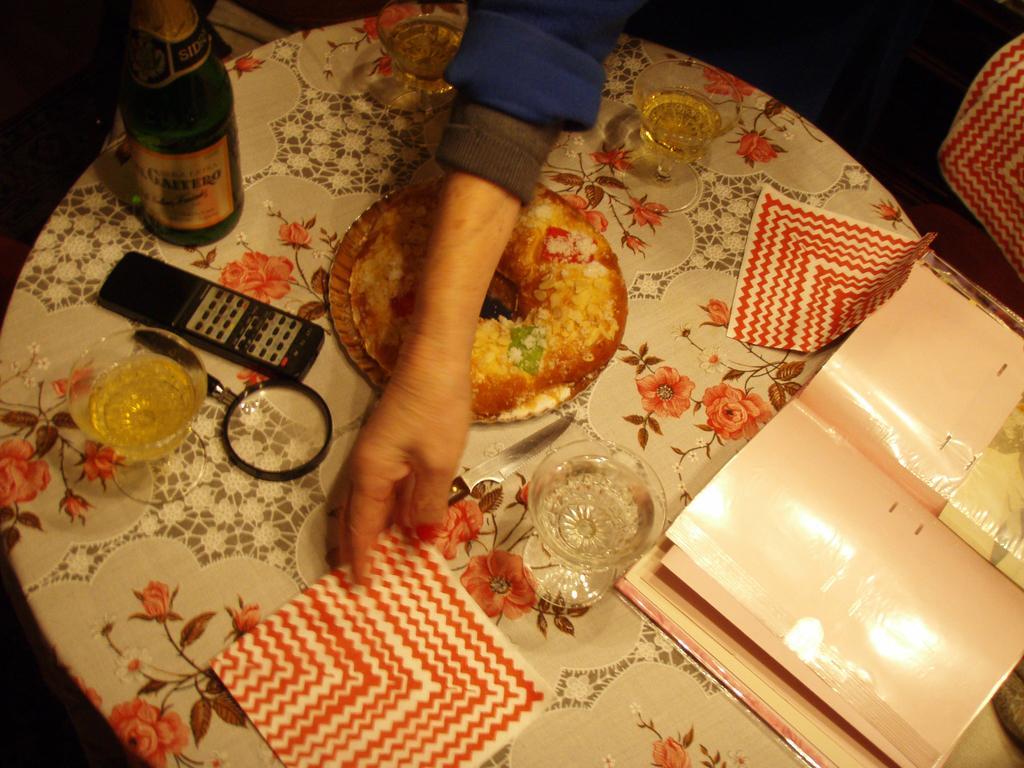Describe this image in one or two sentences. In this picture there is a round dining table with some tissue papers, water glass and on the left side there is a wine bottle and television remote. In the center there is a woman hand. 